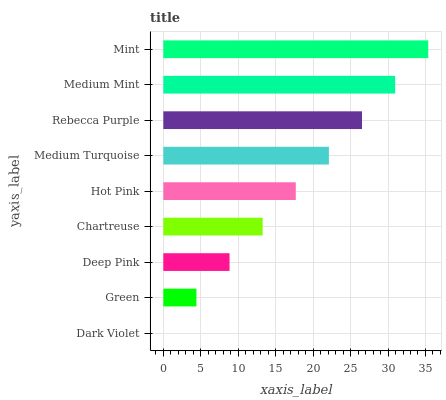Is Dark Violet the minimum?
Answer yes or no. Yes. Is Mint the maximum?
Answer yes or no. Yes. Is Green the minimum?
Answer yes or no. No. Is Green the maximum?
Answer yes or no. No. Is Green greater than Dark Violet?
Answer yes or no. Yes. Is Dark Violet less than Green?
Answer yes or no. Yes. Is Dark Violet greater than Green?
Answer yes or no. No. Is Green less than Dark Violet?
Answer yes or no. No. Is Hot Pink the high median?
Answer yes or no. Yes. Is Hot Pink the low median?
Answer yes or no. Yes. Is Medium Mint the high median?
Answer yes or no. No. Is Green the low median?
Answer yes or no. No. 